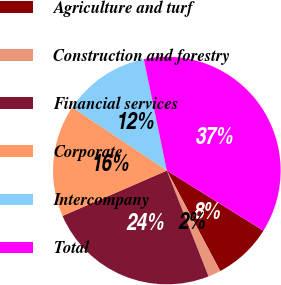Convert chart. <chart><loc_0><loc_0><loc_500><loc_500><pie_chart><fcel>Agriculture and turf<fcel>Construction and forestry<fcel>Financial services<fcel>Corporate<fcel>Intercompany<fcel>Total<nl><fcel>8.36%<fcel>1.8%<fcel>24.44%<fcel>15.9%<fcel>12.37%<fcel>37.11%<nl></chart> 